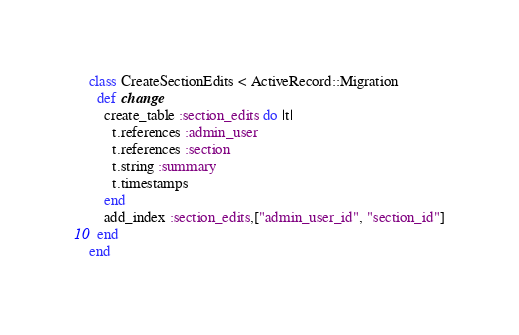Convert code to text. <code><loc_0><loc_0><loc_500><loc_500><_Ruby_>class CreateSectionEdits < ActiveRecord::Migration
  def change
    create_table :section_edits do |t|
      t.references :admin_user
      t.references :section
      t.string :summary
      t.timestamps
    end
    add_index :section_edits,["admin_user_id", "section_id"]
  end
end
</code> 